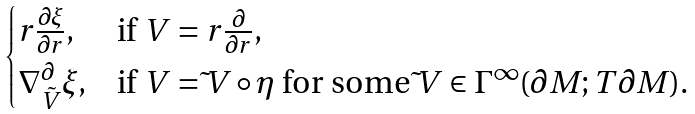<formula> <loc_0><loc_0><loc_500><loc_500>\begin{cases} r \frac { \partial \xi } { \partial r } , & \text {if $V= r\frac{\partial}{\partial r} $} , \\ \nabla ^ { \partial } _ { \tilde { V } } \xi , & \text {if $V= \tilde{ }V \circ \eta$ for some   $\tilde{ }V \in \Gamma^{\infty} (\partial M; T\partial M)$} . \end{cases}</formula> 